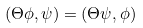Convert formula to latex. <formula><loc_0><loc_0><loc_500><loc_500>( \Theta \phi , \psi ) = ( \Theta \psi , \phi )</formula> 